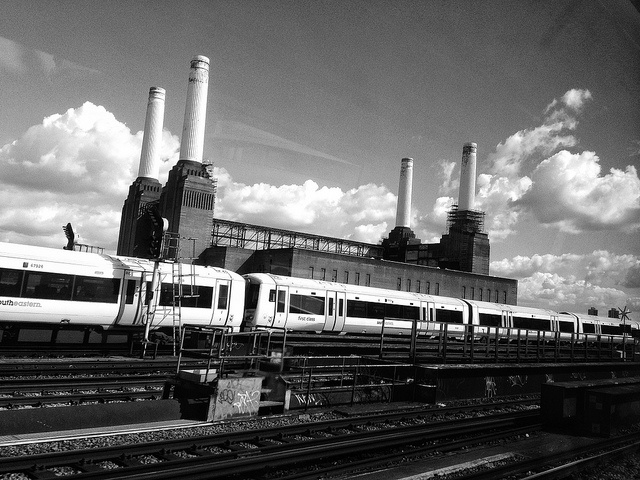Describe the objects in this image and their specific colors. I can see a train in gray, white, black, and darkgray tones in this image. 